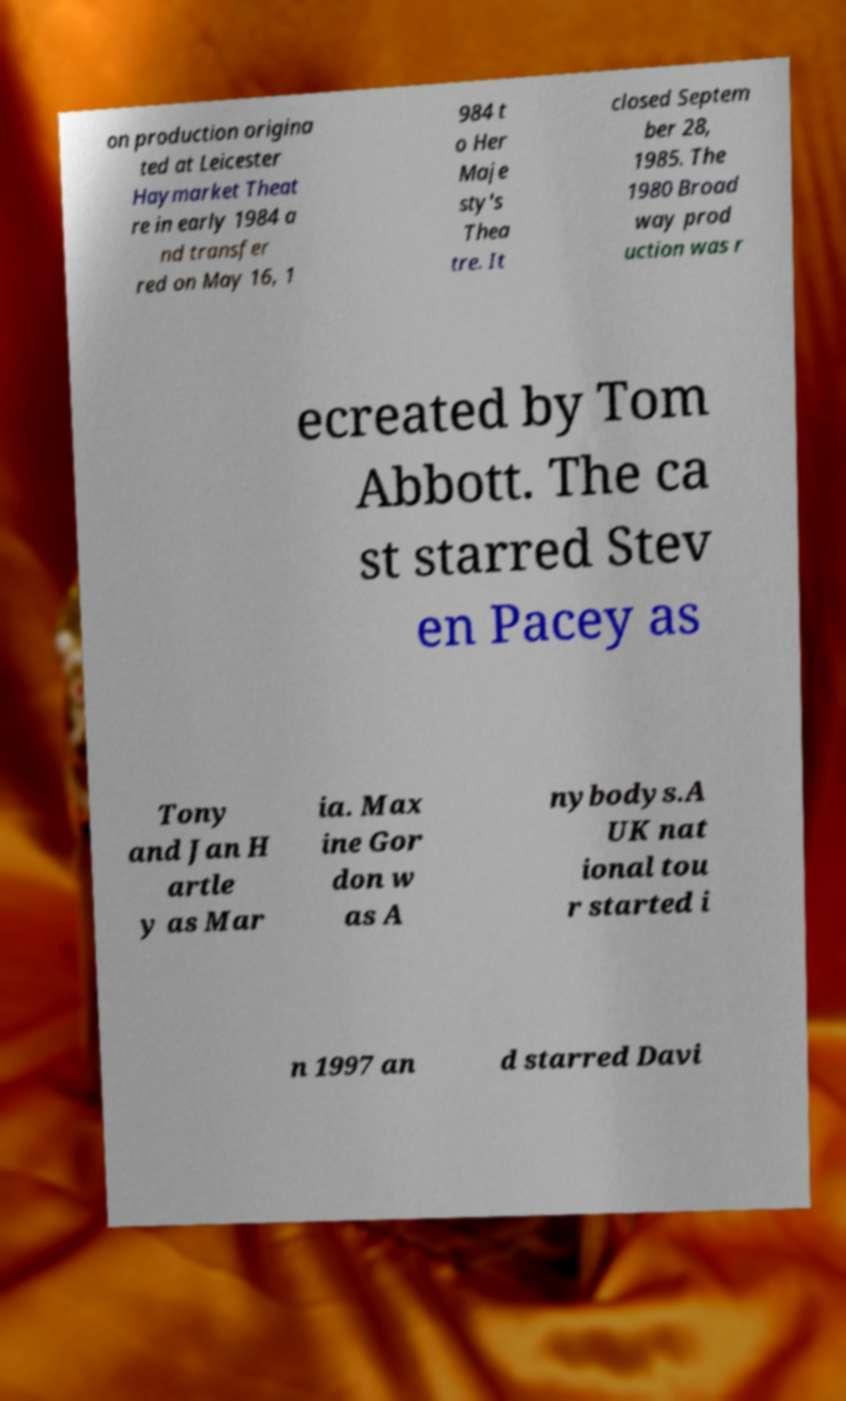Can you accurately transcribe the text from the provided image for me? on production origina ted at Leicester Haymarket Theat re in early 1984 a nd transfer red on May 16, 1 984 t o Her Maje sty's Thea tre. It closed Septem ber 28, 1985. The 1980 Broad way prod uction was r ecreated by Tom Abbott. The ca st starred Stev en Pacey as Tony and Jan H artle y as Mar ia. Max ine Gor don w as A nybodys.A UK nat ional tou r started i n 1997 an d starred Davi 